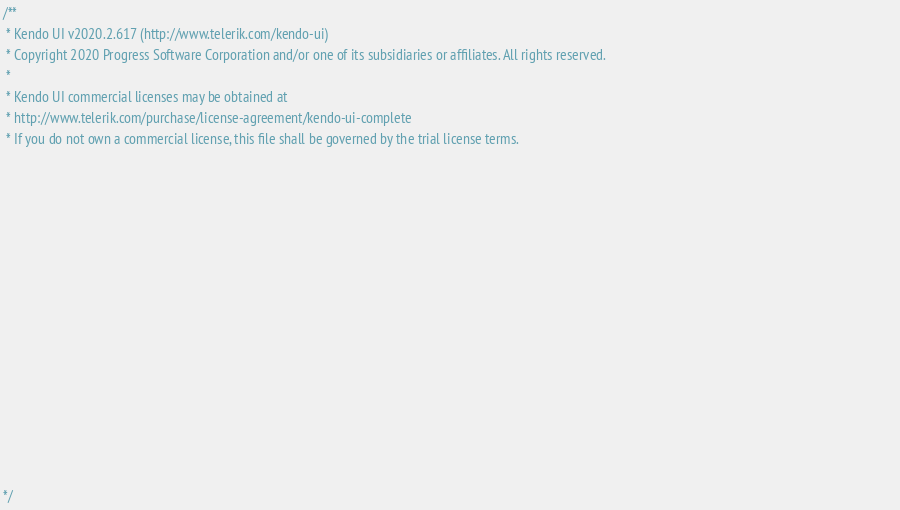Convert code to text. <code><loc_0><loc_0><loc_500><loc_500><_JavaScript_>/** 
 * Kendo UI v2020.2.617 (http://www.telerik.com/kendo-ui)                                                                                                                                               
 * Copyright 2020 Progress Software Corporation and/or one of its subsidiaries or affiliates. All rights reserved.                                                                                      
 *                                                                                                                                                                                                      
 * Kendo UI commercial licenses may be obtained at                                                                                                                                                      
 * http://www.telerik.com/purchase/license-agreement/kendo-ui-complete                                                                                                                                  
 * If you do not own a commercial license, this file shall be governed by the trial license terms.                                                                                                      
                                                                                                                                                                                                       
                                                                                                                                                                                                       
                                                                                                                                                                                                       
                                                                                                                                                                                                       
                                                                                                                                                                                                       
                                                                                                                                                                                                       
                                                                                                                                                                                                       
                                                                                                                                                                                                       
                                                                                                                                                                                                       
                                                                                                                                                                                                       
                                                                                                                                                                                                       
                                                                                                                                                                                                       
                                                                                                                                                                                                       
                                                                                                                                                                                                       
                                                                                                                                                                                                       

*/</code> 